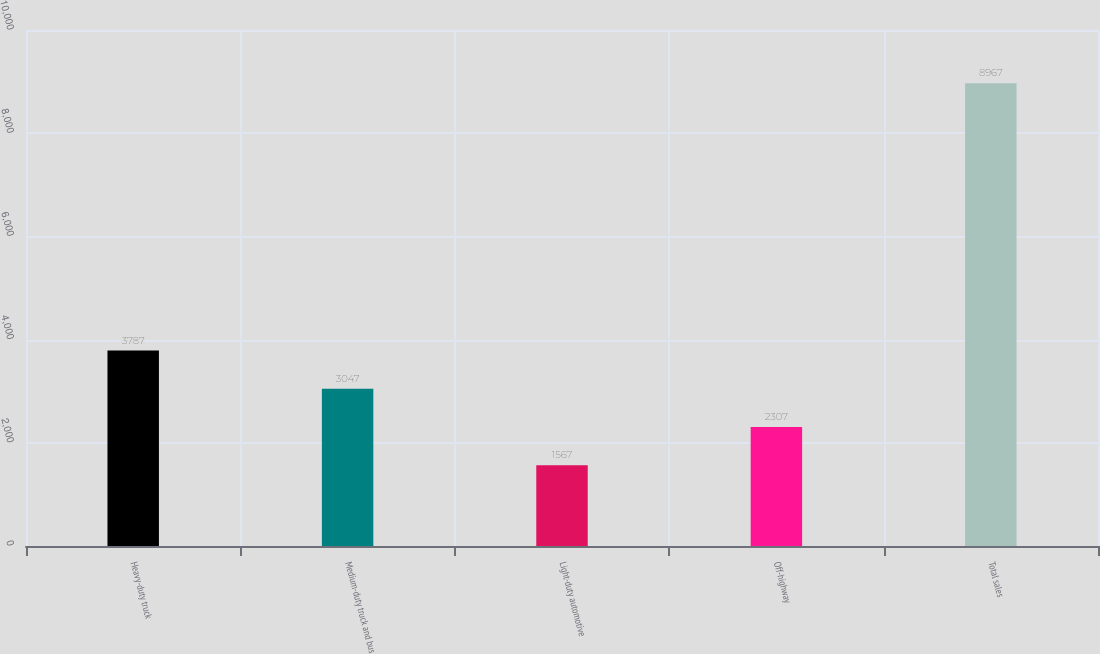Convert chart to OTSL. <chart><loc_0><loc_0><loc_500><loc_500><bar_chart><fcel>Heavy-duty truck<fcel>Medium-duty truck and bus<fcel>Light-duty automotive<fcel>Off-highway<fcel>Total sales<nl><fcel>3787<fcel>3047<fcel>1567<fcel>2307<fcel>8967<nl></chart> 